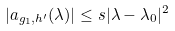<formula> <loc_0><loc_0><loc_500><loc_500>| a _ { g _ { 1 } , h ^ { \prime } } ( \lambda ) | \leq s | \lambda - \lambda _ { 0 } | ^ { 2 }</formula> 